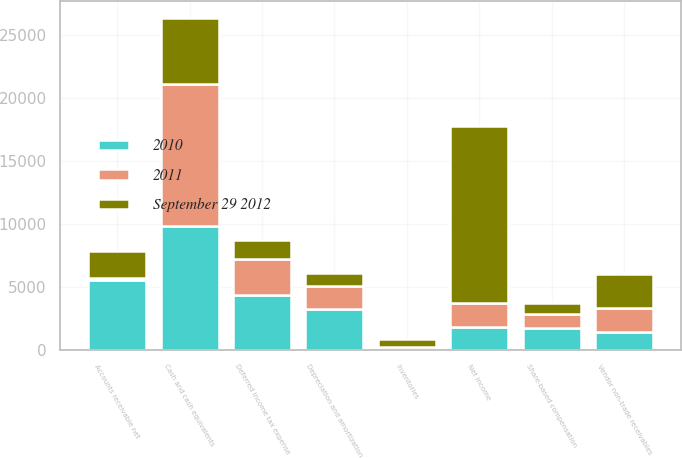Convert chart to OTSL. <chart><loc_0><loc_0><loc_500><loc_500><stacked_bar_chart><ecel><fcel>Cash and cash equivalents<fcel>Net income<fcel>Depreciation and amortization<fcel>Share-based compensation<fcel>Deferred income tax expense<fcel>Accounts receivable net<fcel>Inventories<fcel>Vendor non-trade receivables<nl><fcel>2010<fcel>9815<fcel>1874<fcel>3277<fcel>1740<fcel>4405<fcel>5551<fcel>15<fcel>1414<nl><fcel>2011<fcel>11261<fcel>1874<fcel>1814<fcel>1168<fcel>2868<fcel>143<fcel>275<fcel>1934<nl><fcel>September 29 2012<fcel>5263<fcel>14013<fcel>1027<fcel>879<fcel>1440<fcel>2142<fcel>596<fcel>2718<nl></chart> 